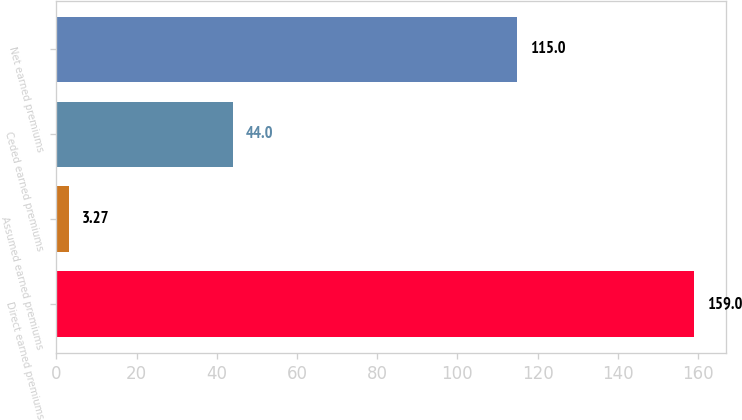<chart> <loc_0><loc_0><loc_500><loc_500><bar_chart><fcel>Direct earned premiums<fcel>Assumed earned premiums<fcel>Ceded earned premiums<fcel>Net earned premiums<nl><fcel>159<fcel>3.27<fcel>44<fcel>115<nl></chart> 